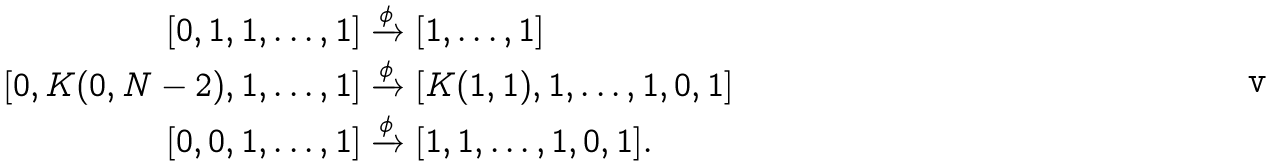Convert formula to latex. <formula><loc_0><loc_0><loc_500><loc_500>[ 0 , 1 , 1 , \dots , 1 ] & \xrightarrow { \phi } [ 1 , \dots , 1 ] \\ [ 0 , K ( 0 , N - 2 ) , 1 , \dots , 1 ] & \xrightarrow { \phi } [ K ( 1 , 1 ) , 1 , \dots , 1 , 0 , 1 ] \\ [ 0 , 0 , 1 , \dots , 1 ] & \xrightarrow { \phi } [ 1 , 1 , \dots , 1 , 0 , 1 ] .</formula> 